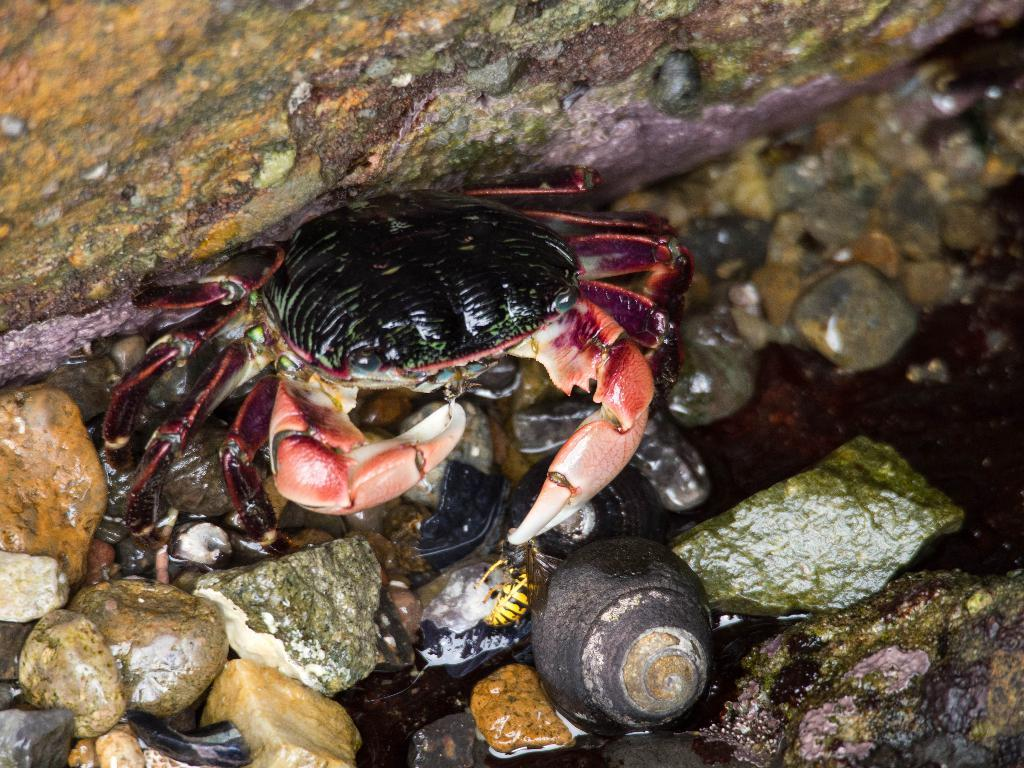What type of natural elements can be seen in the image? There are stones and water in the image. What living creatures are present in the image? There is a snail and a crab in the image. What type of thing is the snail using to keep its hands warm in the image? There is no indication in the image that the snail is using anything to keep its hands warm, as snails do not have hands. 